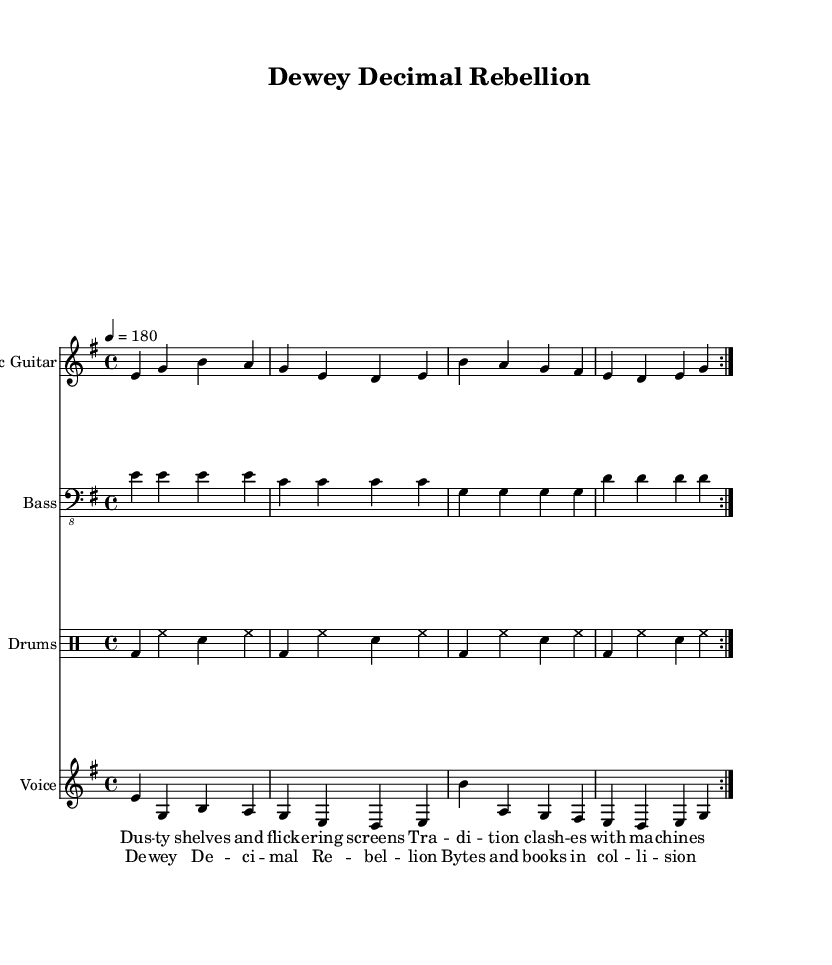What is the key signature of this music? The key signature is shown at the beginning of the score, before the time signature. It indicates that the music is in E minor.
Answer: E minor What is the time signature? The time signature is located just after the key signature, indicating how many beats are in each measure. Here, it shows that there are 4 beats per measure.
Answer: 4/4 What is the tempo marking? The tempo marking is located in the global settings of the piece. It specifies that the tempo is set to 180 beats per minute, indicating a fast pace.
Answer: 180 How many measures are repeated in the electric guitar part? The electric guitar part has a repeat sign indicating that the measures should be played again, which is denoted by "volta 2". This clearly tells us the repetition count.
Answer: 2 What is the primary theme expressed in the lyrics? The lyrics indicate a thematic focus on the conflict between tradition and modern technology, evident in phrases like "Dusty shelves" versus "flickering screens". This juxtaposition is central to the punk ethos.
Answer: Rebellion What instruments are included in this score? The score specifies various instruments, each indicated by a unique staff. The instruments listed include Electric Guitar, Bass, Drums, and Voice.
Answer: Electric Guitar, Bass, Drums, Voice What style of music does this sheet represent? The combination of upbeat tempo, vocals centered around lyrical themes of rebellion, and instrumentation aligns with the characteristics of melodic punk rock. This genre is often defined by its energetic sound and confrontational themes.
Answer: Melodic punk rock 